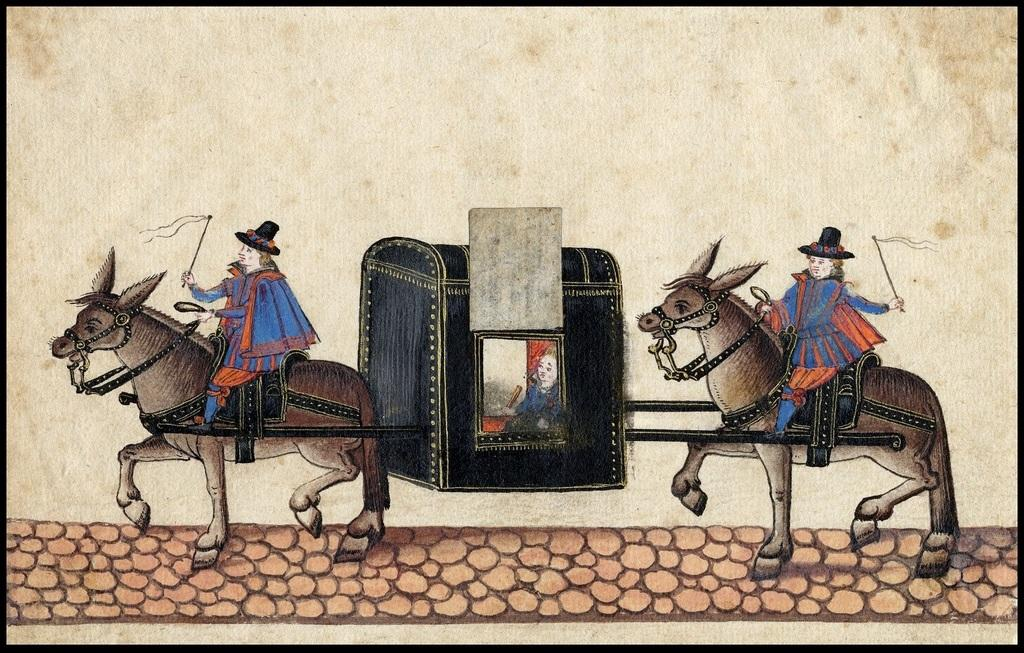What is the main subject of the image? The image contains a painting. What animals are depicted in the painting? There are two horses in the painting. Are there any people in the painting? Yes, there are persons sitting on the horses in the painting. Is there anyone else in the painting besides the persons on horses? Yes, there is a person sitting in a box between the two persons on horses in the painting. What type of liquid can be seen flowing from the horses' mouths in the image? There is no liquid flowing from the horses' mouths in the image; the horses are not depicted in a way that suggests they are drinking or producing any liquid. 